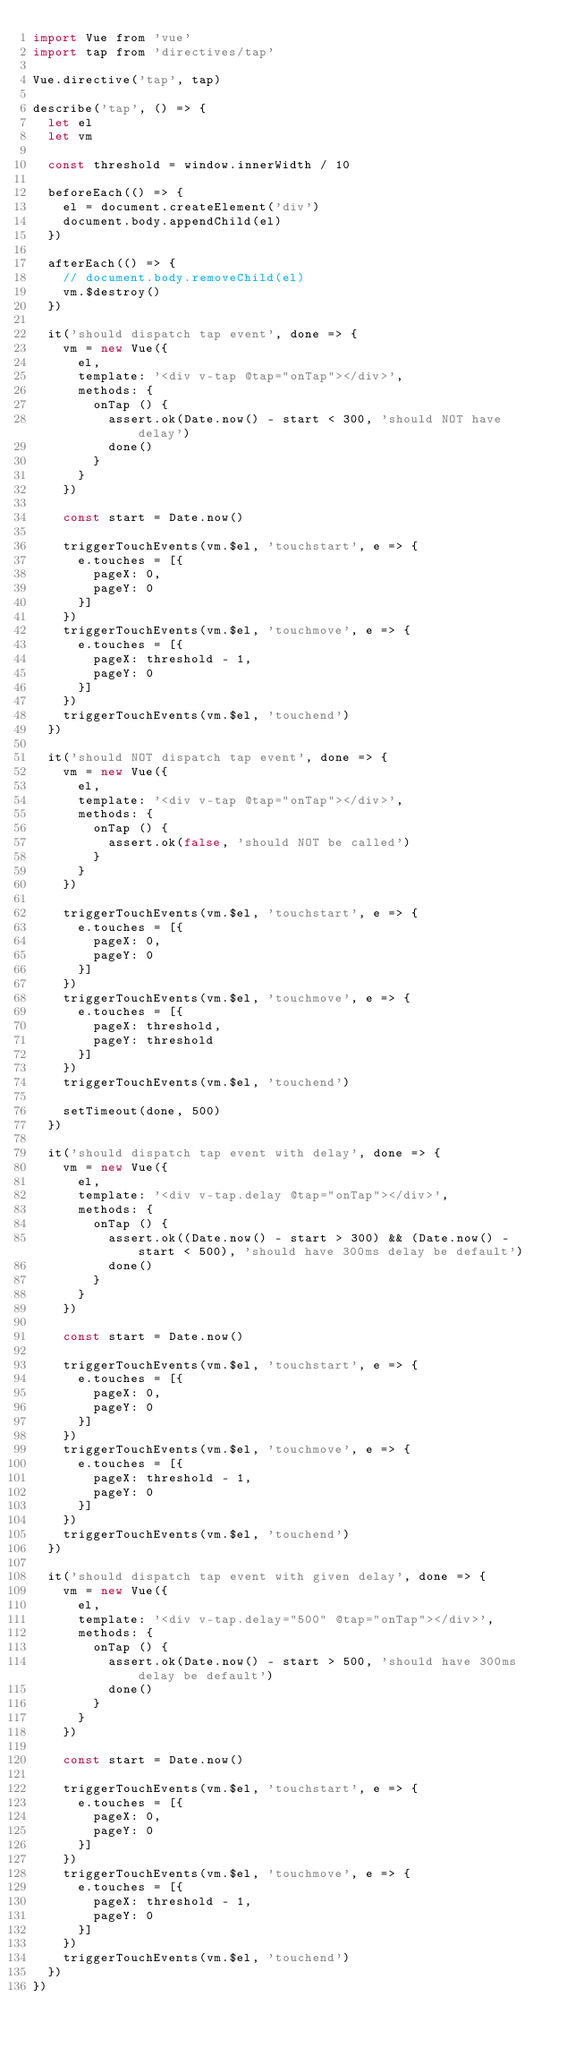<code> <loc_0><loc_0><loc_500><loc_500><_JavaScript_>import Vue from 'vue'
import tap from 'directives/tap'

Vue.directive('tap', tap)

describe('tap', () => {
  let el
  let vm

  const threshold = window.innerWidth / 10

  beforeEach(() => {
    el = document.createElement('div')
    document.body.appendChild(el)
  })

  afterEach(() => {
    // document.body.removeChild(el)
    vm.$destroy()
  })

  it('should dispatch tap event', done => {
    vm = new Vue({
      el,
      template: '<div v-tap @tap="onTap"></div>',
      methods: {
        onTap () {
          assert.ok(Date.now() - start < 300, 'should NOT have delay')
          done()
        }
      }
    })

    const start = Date.now()

    triggerTouchEvents(vm.$el, 'touchstart', e => {
      e.touches = [{
        pageX: 0,
        pageY: 0
      }]
    })
    triggerTouchEvents(vm.$el, 'touchmove', e => {
      e.touches = [{
        pageX: threshold - 1,
        pageY: 0
      }]
    })
    triggerTouchEvents(vm.$el, 'touchend')
  })

  it('should NOT dispatch tap event', done => {
    vm = new Vue({
      el,
      template: '<div v-tap @tap="onTap"></div>',
      methods: {
        onTap () {
          assert.ok(false, 'should NOT be called')
        }
      }
    })

    triggerTouchEvents(vm.$el, 'touchstart', e => {
      e.touches = [{
        pageX: 0,
        pageY: 0
      }]
    })
    triggerTouchEvents(vm.$el, 'touchmove', e => {
      e.touches = [{
        pageX: threshold,
        pageY: threshold
      }]
    })
    triggerTouchEvents(vm.$el, 'touchend')

    setTimeout(done, 500)
  })

  it('should dispatch tap event with delay', done => {
    vm = new Vue({
      el,
      template: '<div v-tap.delay @tap="onTap"></div>',
      methods: {
        onTap () {
          assert.ok((Date.now() - start > 300) && (Date.now() - start < 500), 'should have 300ms delay be default')
          done()
        }
      }
    })

    const start = Date.now()

    triggerTouchEvents(vm.$el, 'touchstart', e => {
      e.touches = [{
        pageX: 0,
        pageY: 0
      }]
    })
    triggerTouchEvents(vm.$el, 'touchmove', e => {
      e.touches = [{
        pageX: threshold - 1,
        pageY: 0
      }]
    })
    triggerTouchEvents(vm.$el, 'touchend')
  })

  it('should dispatch tap event with given delay', done => {
    vm = new Vue({
      el,
      template: '<div v-tap.delay="500" @tap="onTap"></div>',
      methods: {
        onTap () {
          assert.ok(Date.now() - start > 500, 'should have 300ms delay be default')
          done()
        }
      }
    })

    const start = Date.now()

    triggerTouchEvents(vm.$el, 'touchstart', e => {
      e.touches = [{
        pageX: 0,
        pageY: 0
      }]
    })
    triggerTouchEvents(vm.$el, 'touchmove', e => {
      e.touches = [{
        pageX: threshold - 1,
        pageY: 0
      }]
    })
    triggerTouchEvents(vm.$el, 'touchend')
  })
})
</code> 